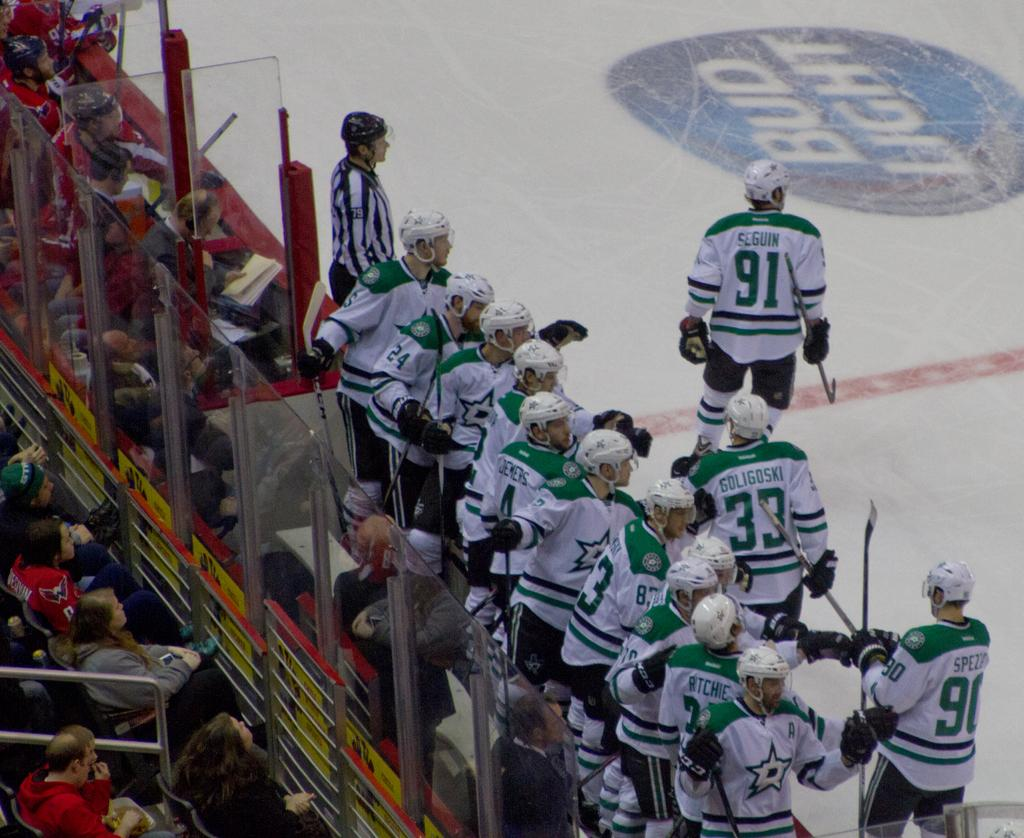<image>
Give a short and clear explanation of the subsequent image. Ice hockey game featuring the Dallas Stars and player Tyler Seguin. 